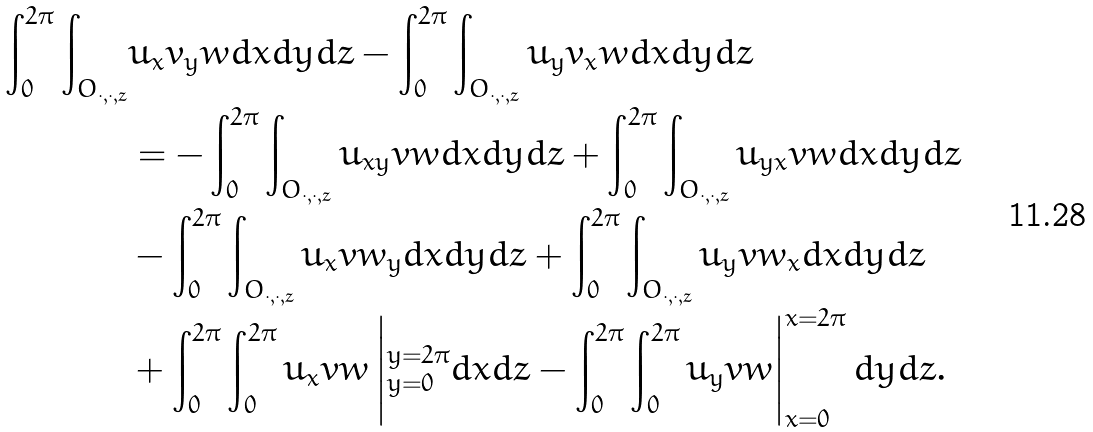Convert formula to latex. <formula><loc_0><loc_0><loc_500><loc_500>\int _ { 0 } ^ { 2 \pi } \int _ { O _ { \cdot , \cdot , z } } & u _ { x } v _ { y } w d x d y d z - \int _ { 0 } ^ { 2 \pi } \int _ { O _ { \cdot , \cdot , z } } u _ { y } v _ { x } w d x d y d z \\ & = - \int _ { 0 } ^ { 2 \pi } \int _ { O _ { \cdot , \cdot , z } } u _ { x y } v w d x d y d z + \int _ { 0 } ^ { 2 \pi } \int _ { O _ { \cdot , \cdot , z } } u _ { y x } v w d x d y d z \\ & - \int _ { 0 } ^ { 2 \pi } \int _ { O _ { \cdot , \cdot , z } } u _ { x } v w _ { y } d x d y d z + \int _ { 0 } ^ { 2 \pi } \int _ { O _ { \cdot , \cdot , z } } u _ { y } v w _ { x } d x d y d z \\ & + \int _ { 0 } ^ { 2 \pi } \int _ { 0 } ^ { 2 \pi } u _ { x } v w \left | _ { y = 0 } ^ { y = 2 \pi } d x d z - \int _ { 0 } ^ { 2 \pi } \int _ { 0 } ^ { 2 \pi } u _ { y } v w \right | _ { x = 0 } ^ { x = 2 \pi } d y d z .</formula> 